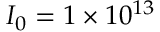Convert formula to latex. <formula><loc_0><loc_0><loc_500><loc_500>I _ { 0 } = 1 \times 1 0 ^ { 1 3 }</formula> 